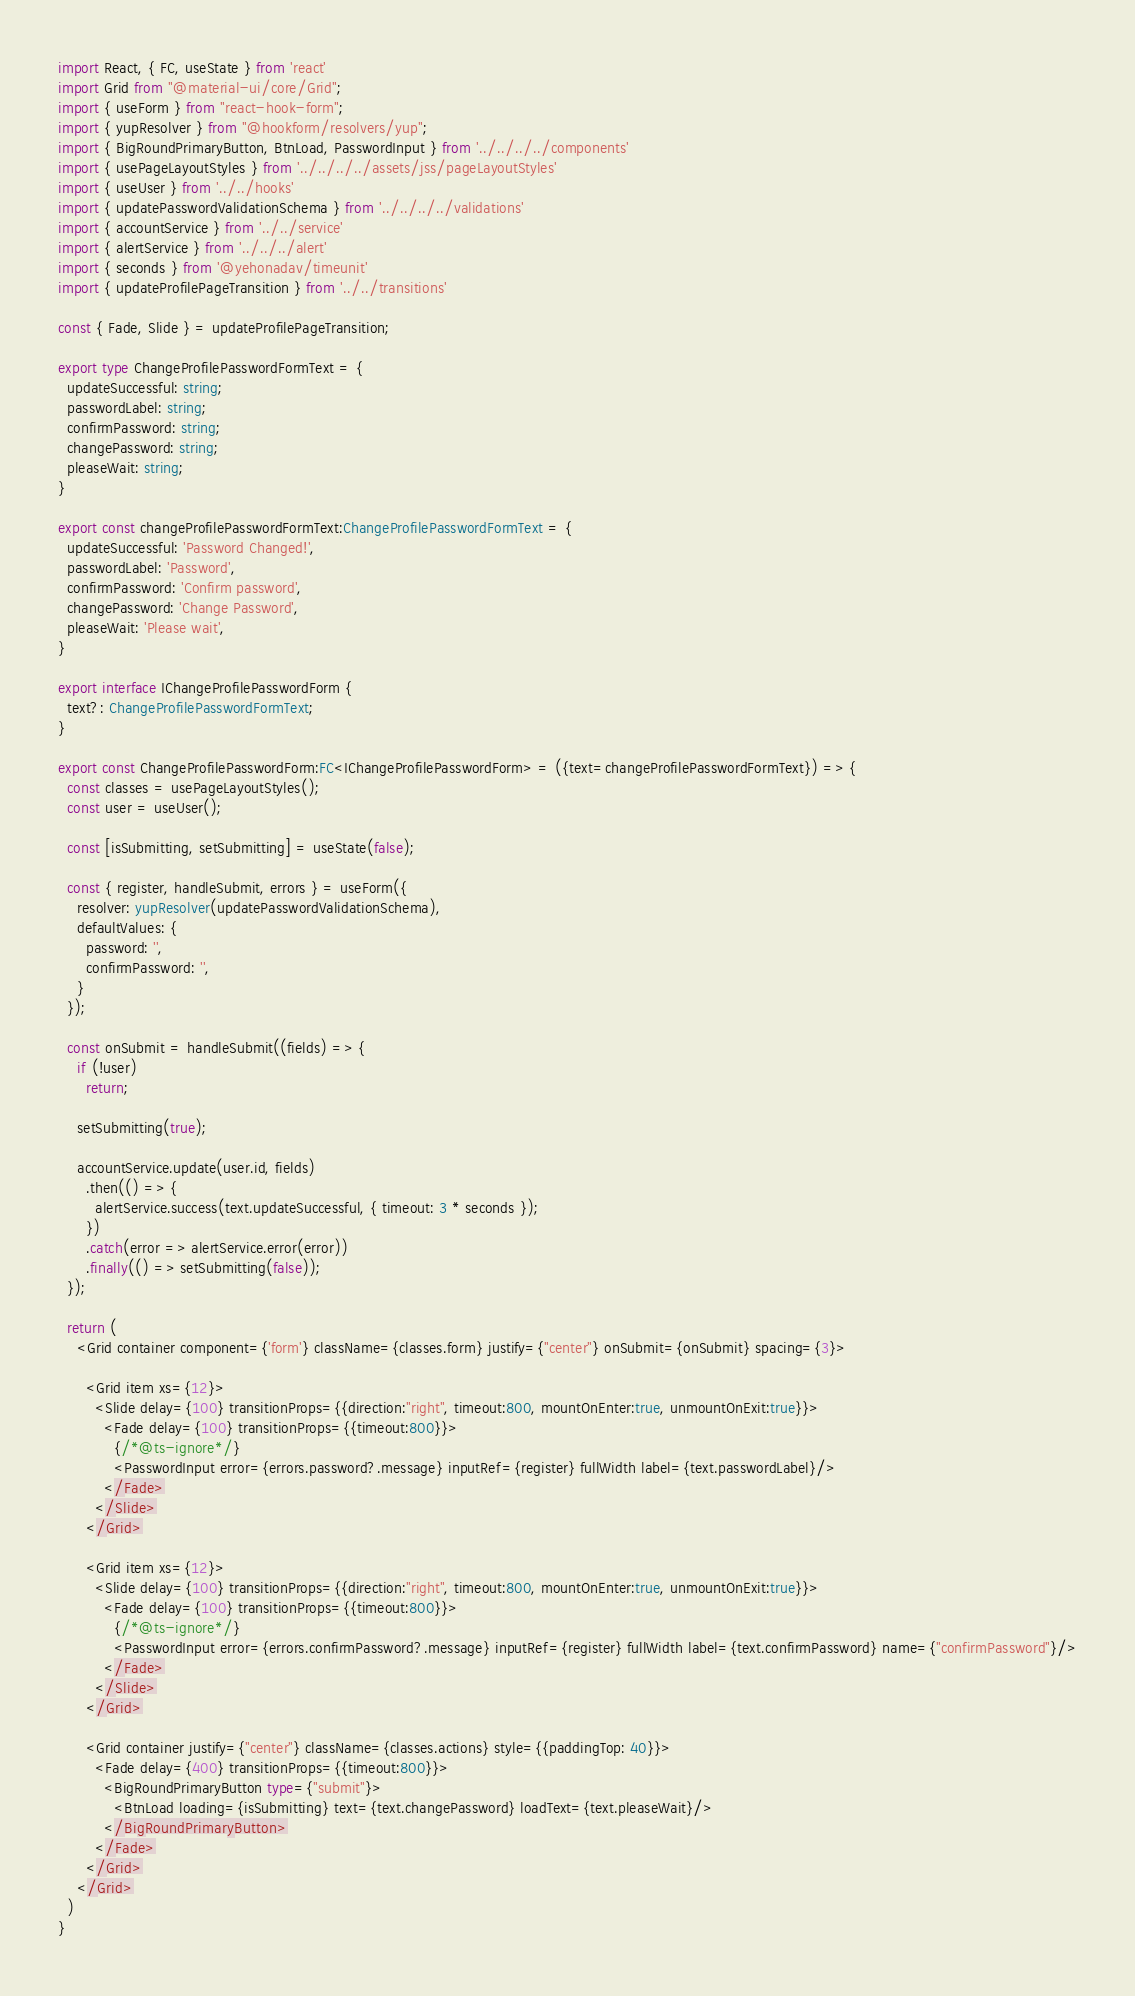<code> <loc_0><loc_0><loc_500><loc_500><_TypeScript_>import React, { FC, useState } from 'react'
import Grid from "@material-ui/core/Grid";
import { useForm } from "react-hook-form";
import { yupResolver } from "@hookform/resolvers/yup";
import { BigRoundPrimaryButton, BtnLoad, PasswordInput } from '../../../../components'
import { usePageLayoutStyles } from '../../../../assets/jss/pageLayoutStyles'
import { useUser } from '../../hooks'
import { updatePasswordValidationSchema } from '../../../../validations'
import { accountService } from '../../service'
import { alertService } from '../../../alert'
import { seconds } from '@yehonadav/timeunit'
import { updateProfilePageTransition } from '../../transitions'

const { Fade, Slide } = updateProfilePageTransition;

export type ChangeProfilePasswordFormText = {
  updateSuccessful: string;
  passwordLabel: string;
  confirmPassword: string;
  changePassword: string;
  pleaseWait: string;
}

export const changeProfilePasswordFormText:ChangeProfilePasswordFormText = {
  updateSuccessful: 'Password Changed!',
  passwordLabel: 'Password',
  confirmPassword: 'Confirm password',
  changePassword: 'Change Password',
  pleaseWait: 'Please wait',
}

export interface IChangeProfilePasswordForm {
  text?: ChangeProfilePasswordFormText;
}

export const ChangeProfilePasswordForm:FC<IChangeProfilePasswordForm> = ({text=changeProfilePasswordFormText}) => {
  const classes = usePageLayoutStyles();
  const user = useUser();

  const [isSubmitting, setSubmitting] = useState(false);

  const { register, handleSubmit, errors } = useForm({
    resolver: yupResolver(updatePasswordValidationSchema),
    defaultValues: {
      password: '',
      confirmPassword: '',
    }
  });

  const onSubmit = handleSubmit((fields) => {
    if (!user)
      return;

    setSubmitting(true);

    accountService.update(user.id, fields)
      .then(() => {
        alertService.success(text.updateSuccessful, { timeout: 3 * seconds });
      })
      .catch(error => alertService.error(error))
      .finally(() => setSubmitting(false));
  });

  return (
    <Grid container component={'form'} className={classes.form} justify={"center"} onSubmit={onSubmit} spacing={3}>

      <Grid item xs={12}>
        <Slide delay={100} transitionProps={{direction:"right", timeout:800, mountOnEnter:true, unmountOnExit:true}}>
          <Fade delay={100} transitionProps={{timeout:800}}>
            {/*@ts-ignore*/}
            <PasswordInput error={errors.password?.message} inputRef={register} fullWidth label={text.passwordLabel}/>
          </Fade>
        </Slide>
      </Grid>

      <Grid item xs={12}>
        <Slide delay={100} transitionProps={{direction:"right", timeout:800, mountOnEnter:true, unmountOnExit:true}}>
          <Fade delay={100} transitionProps={{timeout:800}}>
            {/*@ts-ignore*/}
            <PasswordInput error={errors.confirmPassword?.message} inputRef={register} fullWidth label={text.confirmPassword} name={"confirmPassword"}/>
          </Fade>
        </Slide>
      </Grid>

      <Grid container justify={"center"} className={classes.actions} style={{paddingTop: 40}}>
        <Fade delay={400} transitionProps={{timeout:800}}>
          <BigRoundPrimaryButton type={"submit"}>
            <BtnLoad loading={isSubmitting} text={text.changePassword} loadText={text.pleaseWait}/>
          </BigRoundPrimaryButton>
        </Fade>
      </Grid>
    </Grid>
  )
}</code> 